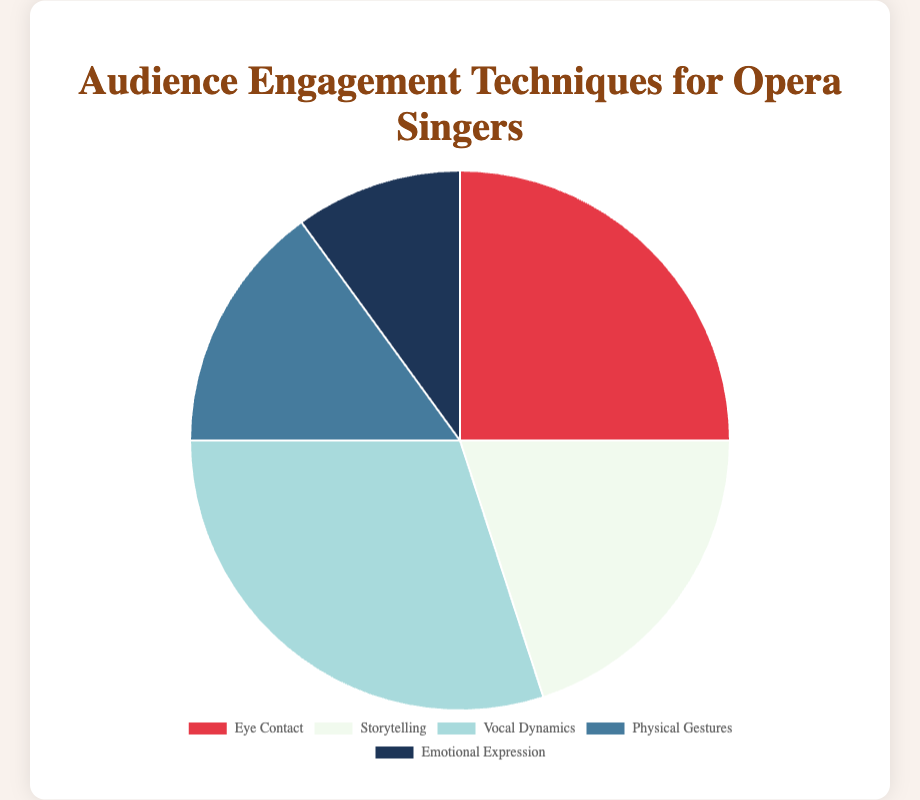What's the most common audience engagement technique displayed? From the pie chart, the segment labeled "Vocal Dynamics" is the largest, which indicates it has the highest percentage among all the techniques displayed.
Answer: Vocal Dynamics Which engagement technique is the least common? The segment labeled "Emotional Expression" is the smallest, which means it has the smallest percentage in the pie chart.
Answer: Emotional Expression Is the percentage of Storytelling more than Physical Gestures? Looking at the pie chart, Storytelling accounts for 20% while Physical Gestures account for 15%. Since 20% is greater than 15%, Storytelling has a higher percentage than Physical Gestures.
Answer: Yes How much larger is the percentage of Vocal Dynamics compared to Emotional Expression? Vocal Dynamics is 30%, while Emotional Expression is 10%. The difference is calculated as 30% - 10% = 20%.
Answer: 20% What is the total percentage of all engagement techniques excluding Eye Contact? We need to add the percentages of all techniques except Eye Contact. That is: 20% (Storytelling) + 30% (Vocal Dynamics) + 15% (Physical Gestures) + 10% (Emotional Expression) = 75%.
Answer: 75% What percentage of techniques combined is Eye Contact and Emotional Expression? The percentage of Eye Contact is 25% and Emotional Expression is 10%. Adding these together gives 25% + 10% = 35%.
Answer: 35% What's the difference between the most and least common techniques? The most common is Vocal Dynamics (30%) and the least common is Emotional Expression (10%). The difference is calculated as 30% - 10% = 20%.
Answer: 20% Which technique is represented by the lightest color in the pie chart? The pie chart shows different colors for each segment. The lightest color is associated with Storytelling.
Answer: Storytelling How much larger is the percentage of Eye Contact compared to Physical Gestures? Eye Contact accounts for 25% and Physical Gestures account for 15%. The difference is 25% - 15% = 10%.
Answer: 10% Are all the techniques cumulatively more than 100% in terms of audience engagement? The total percentage of all techniques should be 100% as it's a pie chart representing the whole. Adding them: 25% + 20% + 30% + 15% + 10% = 100%.
Answer: No 